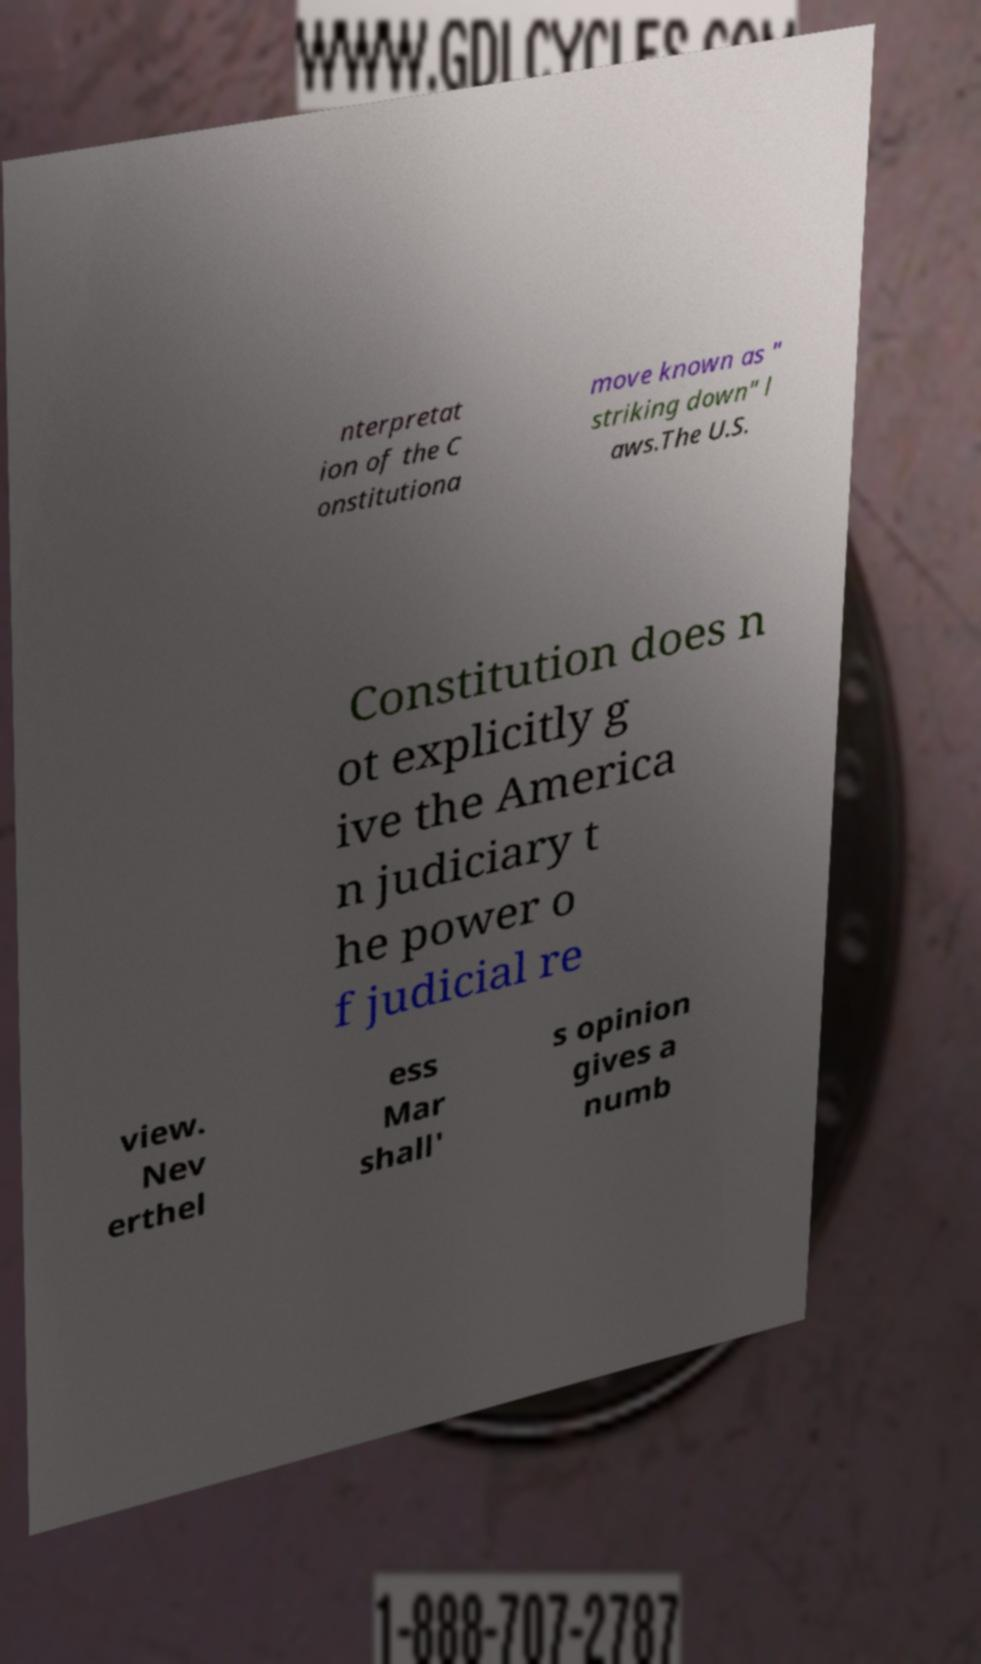Could you assist in decoding the text presented in this image and type it out clearly? nterpretat ion of the C onstitutiona move known as " striking down" l aws.The U.S. Constitution does n ot explicitly g ive the America n judiciary t he power o f judicial re view. Nev erthel ess Mar shall' s opinion gives a numb 